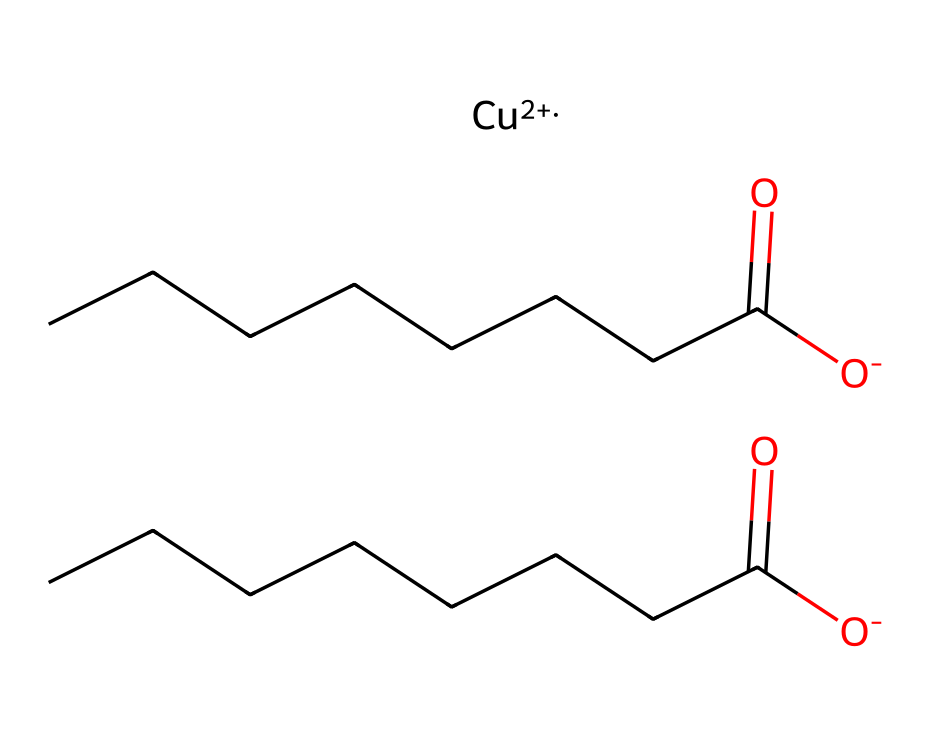What is the central metal atom in this molecule? The chemical structure contains a copper ion, indicated by the presence of '[Cu++]' in the SMILES representation, showing that copper is the central metal atom.
Answer: copper How many octanoate groups are present in the structure of copper octanoate? The structure has two segments of 'C(=O)CCCCCCC', each representing an octanoate group, thus there are two octanoate groups.
Answer: two What charge does the copper ion carry in this molecule? The 'Cu++' notation within the SMILES specifies that the copper ion has a +2 charge, which is essential for its role as a fungicide.
Answer: +2 How many oxygen atoms are present in the entire molecule? Each octanoate group contributes one carbonyl oxygen and one negatively charged oxygen, totaling four oxygen atoms from the two groups and one from the metal coordination, resulting in three oxygen atoms.
Answer: three What type of chemical compound is copper octanoate classified as? Given its use as a fungicide and its metal-organic structure, copper octanoate is classified as a coordination compound, which is characteristic of many fungicides.
Answer: coordination compound What functional groups are present in copper octanoate? The structure contains carboxylate groups (-COO-) from the octanoate moieties, an essential functional group in its classification as a fungicide.
Answer: carboxylate groups 